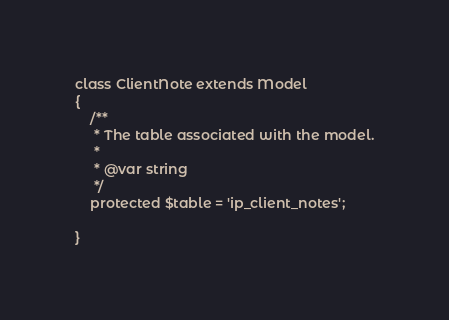<code> <loc_0><loc_0><loc_500><loc_500><_PHP_>
class ClientNote extends Model
{
    /**
     * The table associated with the model.
     *
     * @var string
     */
    protected $table = 'ip_client_notes';

}
</code> 